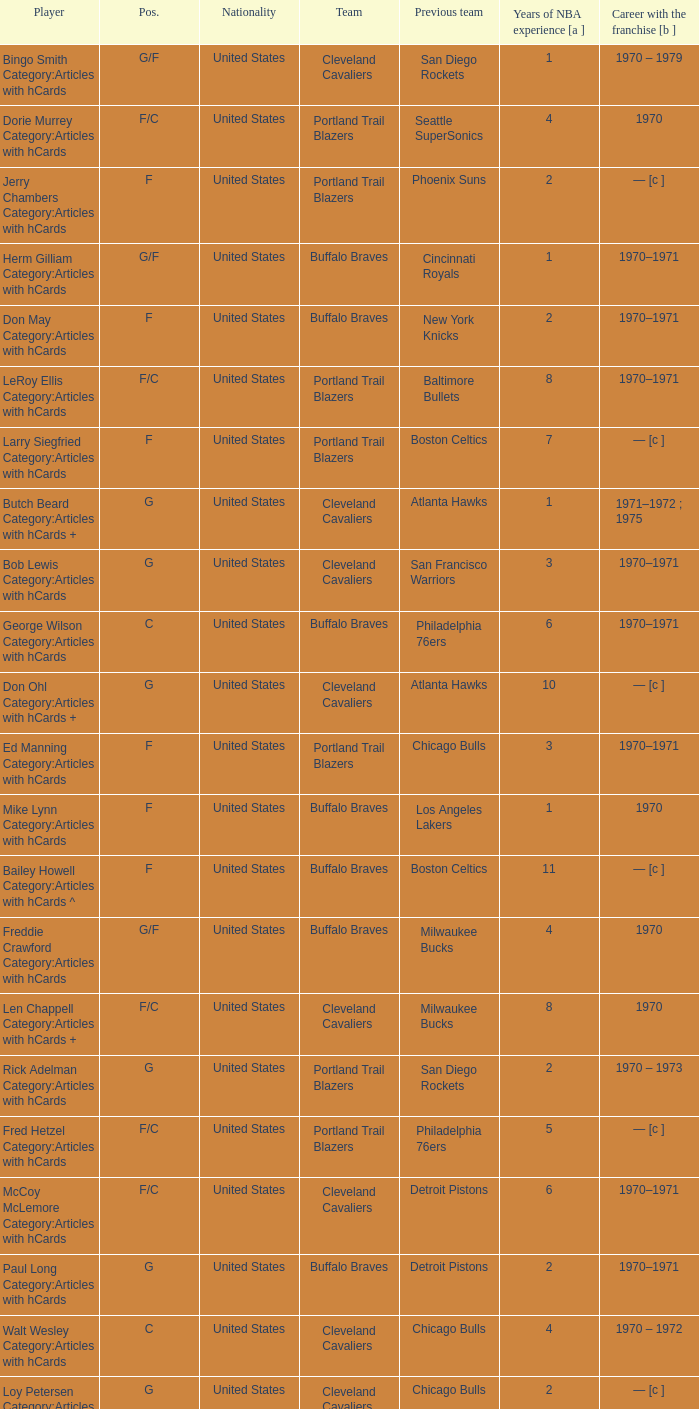How many years of NBA experience does the player who plays position g for the Portland Trail Blazers? 2.0. 